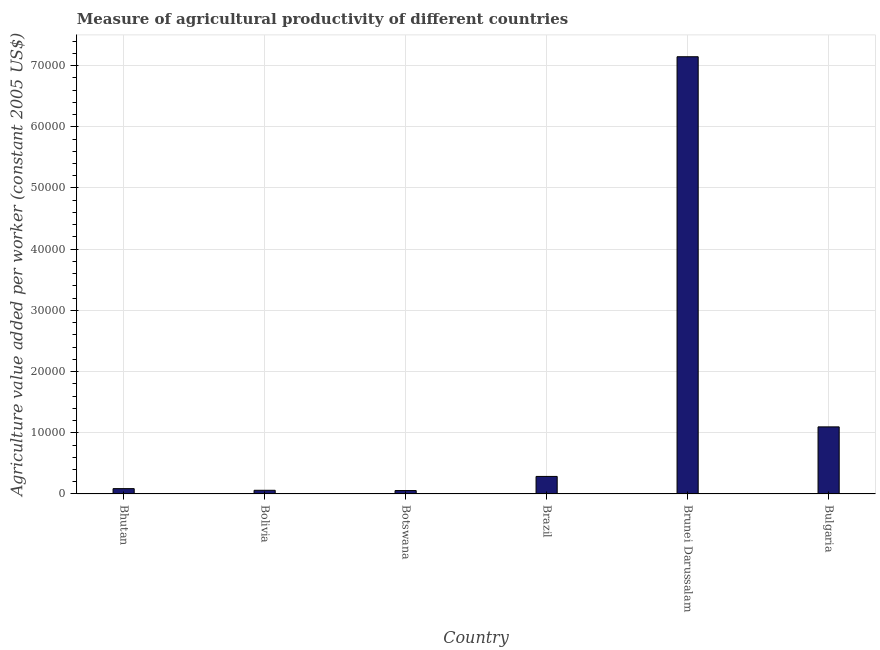Does the graph contain grids?
Your answer should be very brief. Yes. What is the title of the graph?
Ensure brevity in your answer.  Measure of agricultural productivity of different countries. What is the label or title of the Y-axis?
Your answer should be very brief. Agriculture value added per worker (constant 2005 US$). What is the agriculture value added per worker in Bulgaria?
Ensure brevity in your answer.  1.10e+04. Across all countries, what is the maximum agriculture value added per worker?
Ensure brevity in your answer.  7.14e+04. Across all countries, what is the minimum agriculture value added per worker?
Give a very brief answer. 559.09. In which country was the agriculture value added per worker maximum?
Offer a very short reply. Brunei Darussalam. In which country was the agriculture value added per worker minimum?
Offer a terse response. Botswana. What is the sum of the agriculture value added per worker?
Offer a terse response. 8.73e+04. What is the difference between the agriculture value added per worker in Brazil and Brunei Darussalam?
Provide a succinct answer. -6.86e+04. What is the average agriculture value added per worker per country?
Provide a short and direct response. 1.46e+04. What is the median agriculture value added per worker?
Offer a terse response. 1868.78. What is the ratio of the agriculture value added per worker in Bhutan to that in Brazil?
Provide a succinct answer. 0.3. What is the difference between the highest and the second highest agriculture value added per worker?
Offer a terse response. 6.05e+04. What is the difference between the highest and the lowest agriculture value added per worker?
Offer a terse response. 7.09e+04. How many bars are there?
Provide a short and direct response. 6. Are all the bars in the graph horizontal?
Offer a very short reply. No. What is the difference between two consecutive major ticks on the Y-axis?
Make the answer very short. 10000. Are the values on the major ticks of Y-axis written in scientific E-notation?
Offer a very short reply. No. What is the Agriculture value added per worker (constant 2005 US$) in Bhutan?
Your answer should be compact. 871.13. What is the Agriculture value added per worker (constant 2005 US$) in Bolivia?
Offer a terse response. 601.61. What is the Agriculture value added per worker (constant 2005 US$) of Botswana?
Make the answer very short. 559.09. What is the Agriculture value added per worker (constant 2005 US$) of Brazil?
Your response must be concise. 2866.43. What is the Agriculture value added per worker (constant 2005 US$) in Brunei Darussalam?
Ensure brevity in your answer.  7.14e+04. What is the Agriculture value added per worker (constant 2005 US$) of Bulgaria?
Keep it short and to the point. 1.10e+04. What is the difference between the Agriculture value added per worker (constant 2005 US$) in Bhutan and Bolivia?
Provide a succinct answer. 269.51. What is the difference between the Agriculture value added per worker (constant 2005 US$) in Bhutan and Botswana?
Ensure brevity in your answer.  312.03. What is the difference between the Agriculture value added per worker (constant 2005 US$) in Bhutan and Brazil?
Your answer should be very brief. -1995.3. What is the difference between the Agriculture value added per worker (constant 2005 US$) in Bhutan and Brunei Darussalam?
Give a very brief answer. -7.06e+04. What is the difference between the Agriculture value added per worker (constant 2005 US$) in Bhutan and Bulgaria?
Provide a short and direct response. -1.01e+04. What is the difference between the Agriculture value added per worker (constant 2005 US$) in Bolivia and Botswana?
Keep it short and to the point. 42.52. What is the difference between the Agriculture value added per worker (constant 2005 US$) in Bolivia and Brazil?
Provide a short and direct response. -2264.82. What is the difference between the Agriculture value added per worker (constant 2005 US$) in Bolivia and Brunei Darussalam?
Your answer should be compact. -7.08e+04. What is the difference between the Agriculture value added per worker (constant 2005 US$) in Bolivia and Bulgaria?
Offer a very short reply. -1.04e+04. What is the difference between the Agriculture value added per worker (constant 2005 US$) in Botswana and Brazil?
Provide a succinct answer. -2307.34. What is the difference between the Agriculture value added per worker (constant 2005 US$) in Botswana and Brunei Darussalam?
Give a very brief answer. -7.09e+04. What is the difference between the Agriculture value added per worker (constant 2005 US$) in Botswana and Bulgaria?
Offer a terse response. -1.04e+04. What is the difference between the Agriculture value added per worker (constant 2005 US$) in Brazil and Brunei Darussalam?
Provide a succinct answer. -6.86e+04. What is the difference between the Agriculture value added per worker (constant 2005 US$) in Brazil and Bulgaria?
Ensure brevity in your answer.  -8097.49. What is the difference between the Agriculture value added per worker (constant 2005 US$) in Brunei Darussalam and Bulgaria?
Keep it short and to the point. 6.05e+04. What is the ratio of the Agriculture value added per worker (constant 2005 US$) in Bhutan to that in Bolivia?
Make the answer very short. 1.45. What is the ratio of the Agriculture value added per worker (constant 2005 US$) in Bhutan to that in Botswana?
Ensure brevity in your answer.  1.56. What is the ratio of the Agriculture value added per worker (constant 2005 US$) in Bhutan to that in Brazil?
Ensure brevity in your answer.  0.3. What is the ratio of the Agriculture value added per worker (constant 2005 US$) in Bhutan to that in Brunei Darussalam?
Keep it short and to the point. 0.01. What is the ratio of the Agriculture value added per worker (constant 2005 US$) in Bhutan to that in Bulgaria?
Ensure brevity in your answer.  0.08. What is the ratio of the Agriculture value added per worker (constant 2005 US$) in Bolivia to that in Botswana?
Your answer should be very brief. 1.08. What is the ratio of the Agriculture value added per worker (constant 2005 US$) in Bolivia to that in Brazil?
Ensure brevity in your answer.  0.21. What is the ratio of the Agriculture value added per worker (constant 2005 US$) in Bolivia to that in Brunei Darussalam?
Your answer should be very brief. 0.01. What is the ratio of the Agriculture value added per worker (constant 2005 US$) in Bolivia to that in Bulgaria?
Ensure brevity in your answer.  0.06. What is the ratio of the Agriculture value added per worker (constant 2005 US$) in Botswana to that in Brazil?
Provide a succinct answer. 0.2. What is the ratio of the Agriculture value added per worker (constant 2005 US$) in Botswana to that in Brunei Darussalam?
Keep it short and to the point. 0.01. What is the ratio of the Agriculture value added per worker (constant 2005 US$) in Botswana to that in Bulgaria?
Your answer should be compact. 0.05. What is the ratio of the Agriculture value added per worker (constant 2005 US$) in Brazil to that in Brunei Darussalam?
Your answer should be compact. 0.04. What is the ratio of the Agriculture value added per worker (constant 2005 US$) in Brazil to that in Bulgaria?
Make the answer very short. 0.26. What is the ratio of the Agriculture value added per worker (constant 2005 US$) in Brunei Darussalam to that in Bulgaria?
Provide a succinct answer. 6.52. 